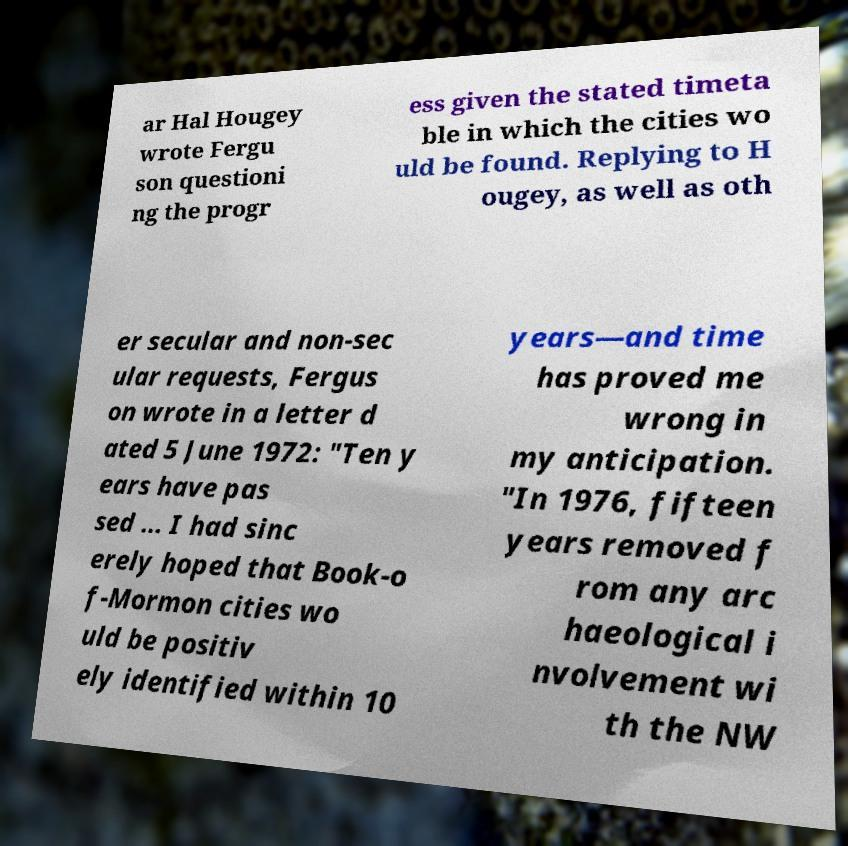For documentation purposes, I need the text within this image transcribed. Could you provide that? ar Hal Hougey wrote Fergu son questioni ng the progr ess given the stated timeta ble in which the cities wo uld be found. Replying to H ougey, as well as oth er secular and non-sec ular requests, Fergus on wrote in a letter d ated 5 June 1972: "Ten y ears have pas sed ... I had sinc erely hoped that Book-o f-Mormon cities wo uld be positiv ely identified within 10 years—and time has proved me wrong in my anticipation. "In 1976, fifteen years removed f rom any arc haeological i nvolvement wi th the NW 